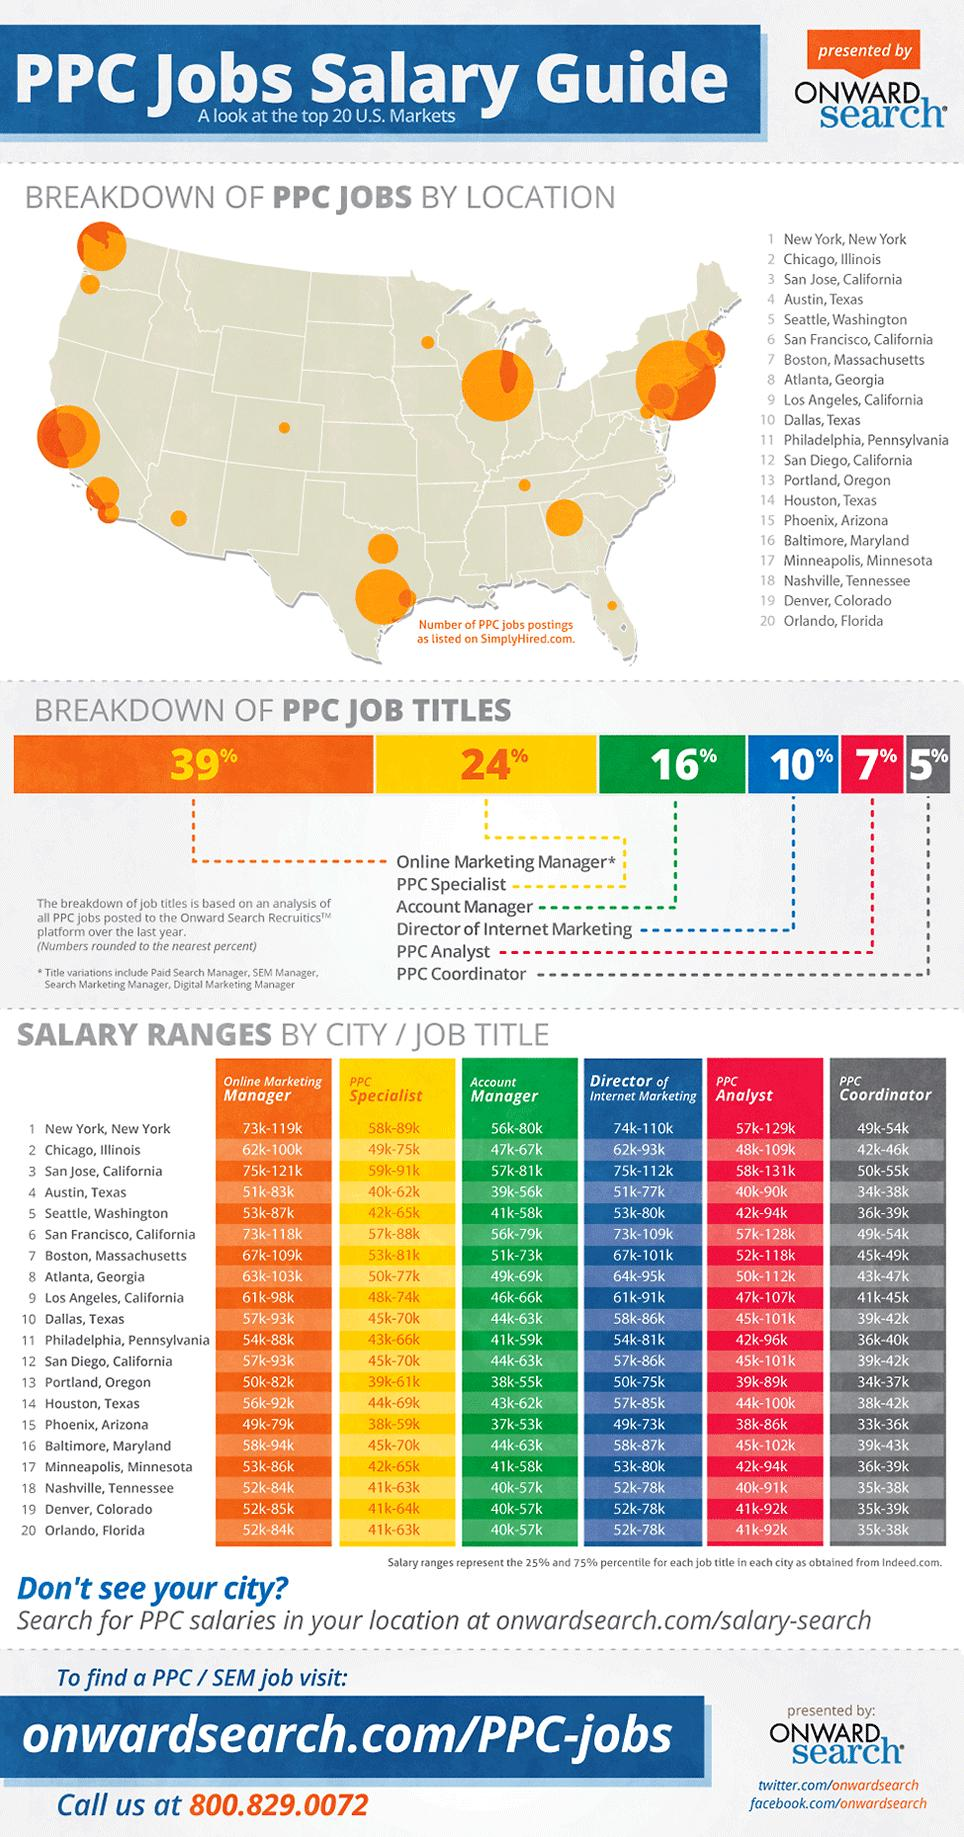Specify some key components in this picture. Ninety-four percent of all PPC job titles do not include the term PPC analyst. Out of all PPC job titles, except for PPC specialist, 77% belong to a broader category. 85% of all PPC job titles, excluding the account manager, have been accounted for in the total percentage breakdown. 